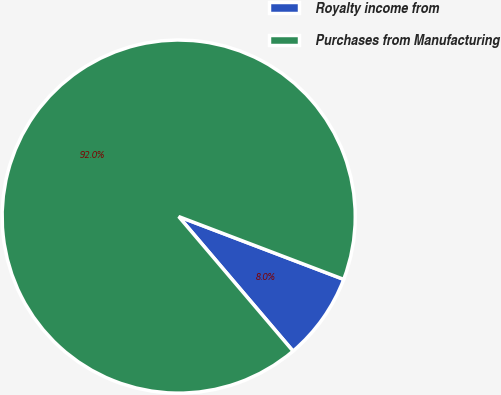<chart> <loc_0><loc_0><loc_500><loc_500><pie_chart><fcel>Royalty income from<fcel>Purchases from Manufacturing<nl><fcel>8.0%<fcel>92.0%<nl></chart> 